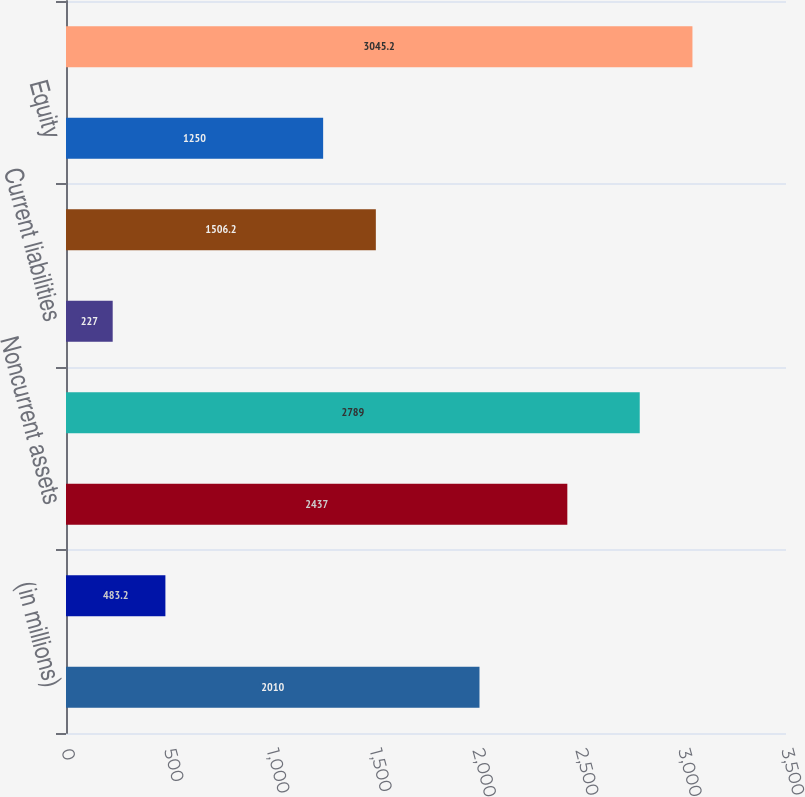<chart> <loc_0><loc_0><loc_500><loc_500><bar_chart><fcel>(in millions)<fcel>Current assets<fcel>Noncurrent assets<fcel>Total assets<fcel>Current liabilities<fcel>Noncurrent liabilities<fcel>Equity<fcel>Total liabilities and equity<nl><fcel>2010<fcel>483.2<fcel>2437<fcel>2789<fcel>227<fcel>1506.2<fcel>1250<fcel>3045.2<nl></chart> 